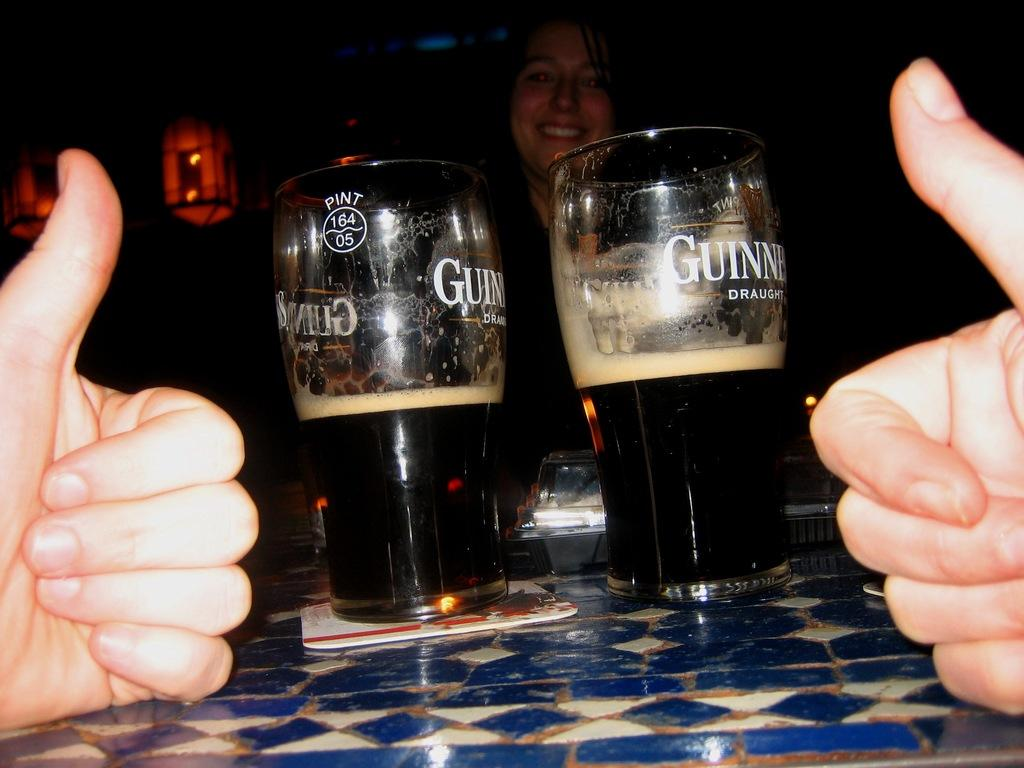<image>
Offer a succinct explanation of the picture presented. Two bottles of beer with Guinness written on the side. 